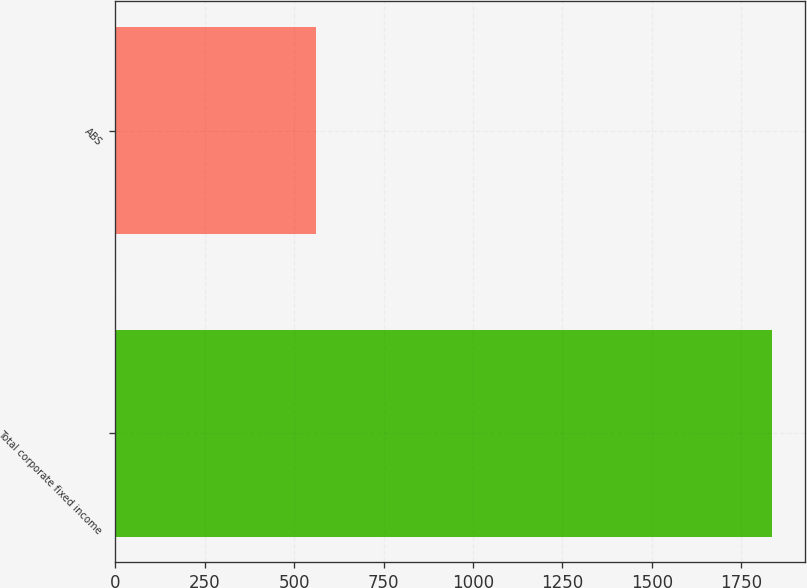<chart> <loc_0><loc_0><loc_500><loc_500><bar_chart><fcel>Total corporate fixed income<fcel>ABS<nl><fcel>1836<fcel>561<nl></chart> 